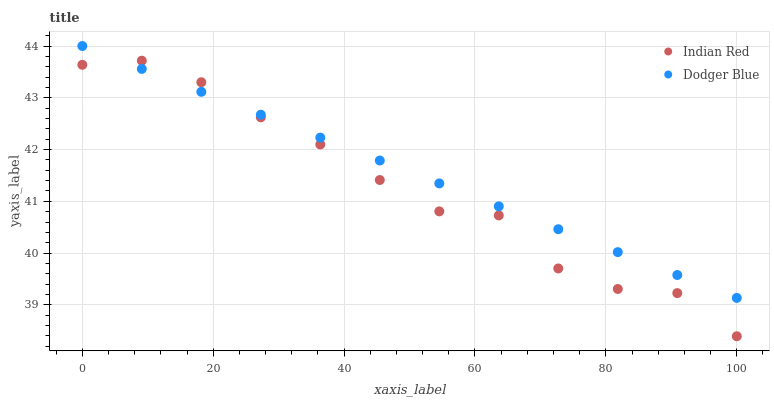Does Indian Red have the minimum area under the curve?
Answer yes or no. Yes. Does Dodger Blue have the maximum area under the curve?
Answer yes or no. Yes. Does Indian Red have the maximum area under the curve?
Answer yes or no. No. Is Dodger Blue the smoothest?
Answer yes or no. Yes. Is Indian Red the roughest?
Answer yes or no. Yes. Is Indian Red the smoothest?
Answer yes or no. No. Does Indian Red have the lowest value?
Answer yes or no. Yes. Does Dodger Blue have the highest value?
Answer yes or no. Yes. Does Indian Red have the highest value?
Answer yes or no. No. Does Indian Red intersect Dodger Blue?
Answer yes or no. Yes. Is Indian Red less than Dodger Blue?
Answer yes or no. No. Is Indian Red greater than Dodger Blue?
Answer yes or no. No. 